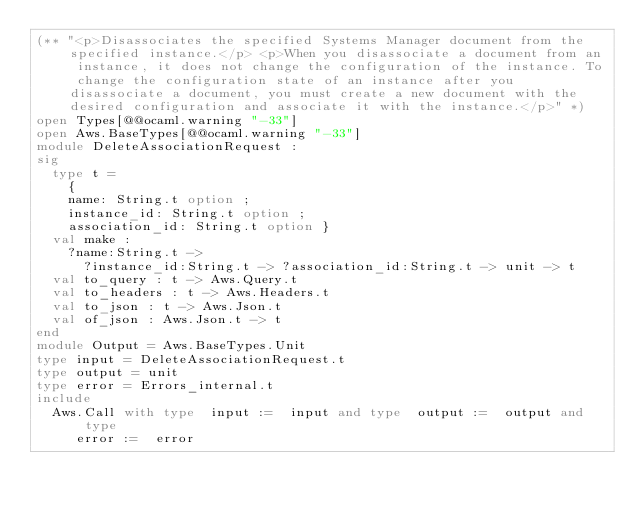<code> <loc_0><loc_0><loc_500><loc_500><_OCaml_>(** "<p>Disassociates the specified Systems Manager document from the specified instance.</p> <p>When you disassociate a document from an instance, it does not change the configuration of the instance. To change the configuration state of an instance after you disassociate a document, you must create a new document with the desired configuration and associate it with the instance.</p>" *)
open Types[@@ocaml.warning "-33"]
open Aws.BaseTypes[@@ocaml.warning "-33"]
module DeleteAssociationRequest :
sig
  type t =
    {
    name: String.t option ;
    instance_id: String.t option ;
    association_id: String.t option }
  val make :
    ?name:String.t ->
      ?instance_id:String.t -> ?association_id:String.t -> unit -> t
  val to_query : t -> Aws.Query.t
  val to_headers : t -> Aws.Headers.t
  val to_json : t -> Aws.Json.t
  val of_json : Aws.Json.t -> t
end
module Output = Aws.BaseTypes.Unit
type input = DeleteAssociationRequest.t
type output = unit
type error = Errors_internal.t
include
  Aws.Call with type  input :=  input and type  output :=  output and type
     error :=  error</code> 